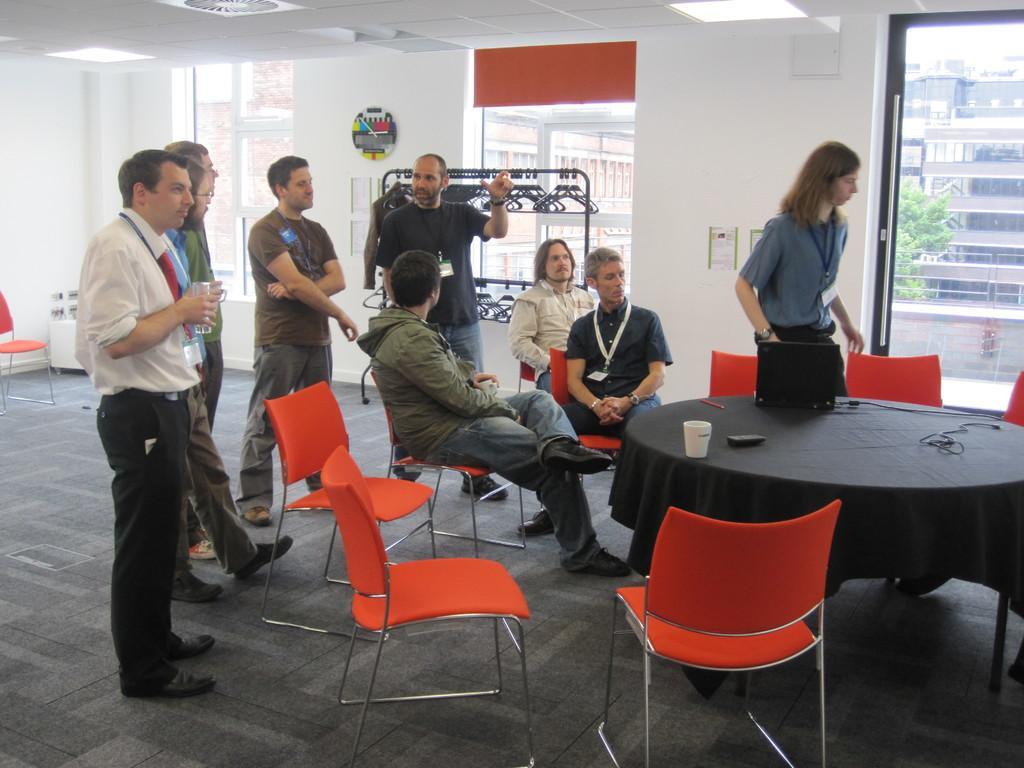How would you summarize this image in a sentence or two? In this image I can see group of people among them some are standing and some are sitting on the chairs. I can also see some empty chairs. Here I can see a table on which I can see a glass, laptop, wires and other objects on it. In the background I can see a wall which has some objects attached to it. Here I can see windows and buildings. I can also see lights on the ceiling. 